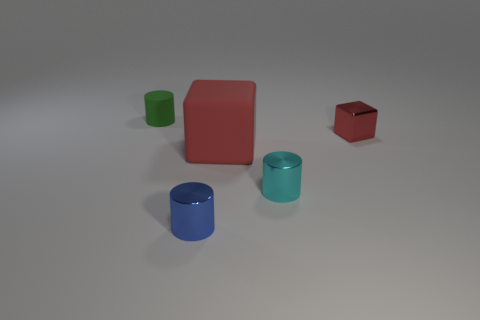Add 5 rubber blocks. How many objects exist? 10 Subtract all blocks. How many objects are left? 3 Add 5 red shiny balls. How many red shiny balls exist? 5 Subtract 0 yellow cubes. How many objects are left? 5 Subtract all metal cubes. Subtract all small blue cylinders. How many objects are left? 3 Add 2 large red rubber things. How many large red rubber things are left? 3 